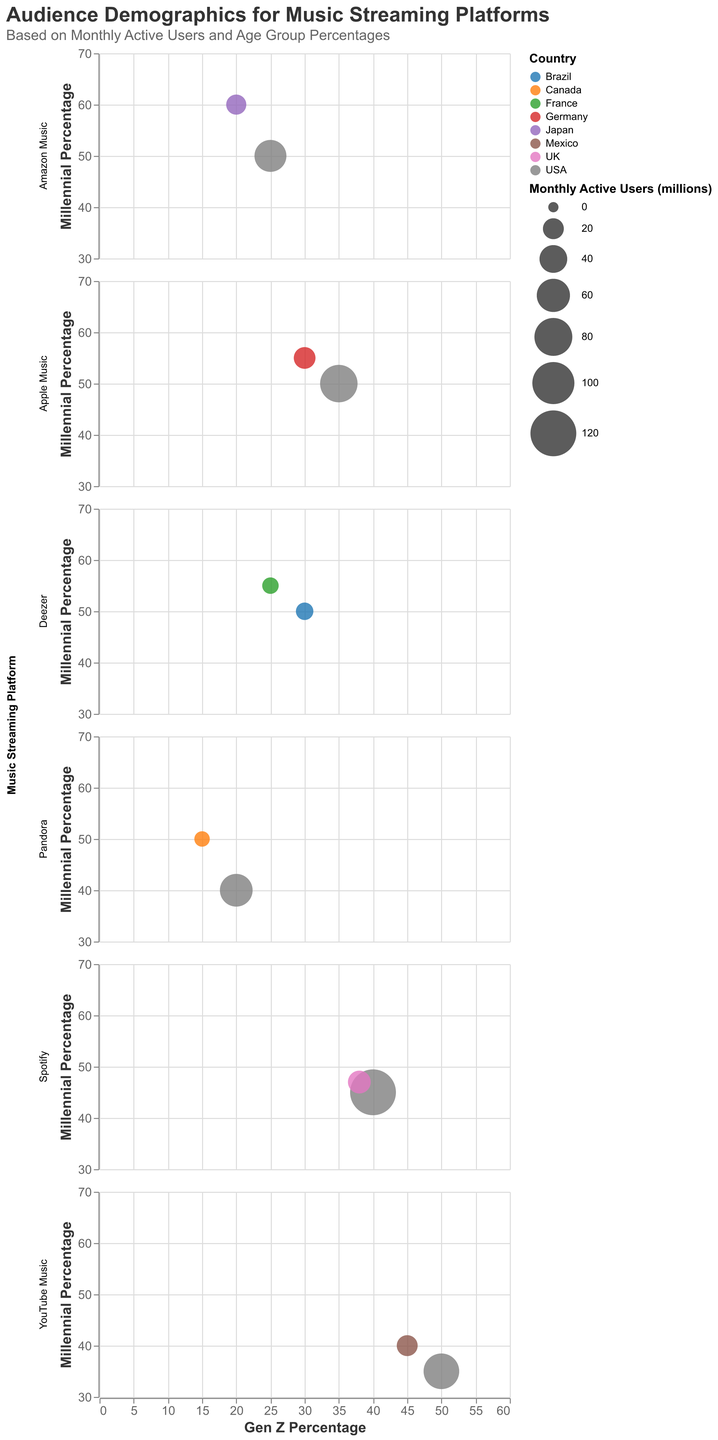What is the platform with the highest percentage of Gen Z users? The subplot with the highest Gen Z percentage can be identified by looking for the circle that is furthest to the right on the x-axis across all subplots.
Answer: YouTube Music (USA) Which demographic has the largest bubble size in the Spotify subplot? By examining the subplot for Spotify, we need to identify the largest bubble which represents the highest monthly active users.
Answer: USA What is the average listening time for Amazon Music in Japan? In the subplot for Amazon Music, locate the circle representing Japan and refer to its tooltip for the average listening time information.
Answer: 11 hours Compare the Gen Z and Millennial percentages for YouTube Music in Mexico. Which is higher? For YouTube Music in Mexico, we compare the position of the corresponding circle on the x and y axes. The circle should be further right for Gen Z if it is higher and further up for Millennials if it is higher.
Answer: Gen Z Which platform in the USA has the smallest percentage of Gen Z users? Focus on the subplots for platforms that include the USA and identify the one with the lowest x-axis value for the USA circle.
Answer: Pandora How do the monthly active users of Apple Music in Germany compare to Deezer in France? Compare the bubble sizes by looking at the subplots for Apple Music (Germany) and Deezer (France) to determine which one is larger.
Answer: Apple Music in Germany has more users What is the sum of the Millennial percentages for Deezer in France and Brazil? Locate the circles for Deezer in France and Brazil and add their y-axis values. France has 55% Millennial percentage and Brazil has 50%.
Answer: 105% Which platform has the highest average listening time and for which demographic? Find the circle in all subplots that is positioned highest on the y-axis, then check its tooltip to confirm the exact average listening time and corresponding demographic.
Answer: YouTube Music (Mexico) What is the Boomer percentage for Pandora in Canada? Locate the Pandora subplot, find the circle for Canada, and refer to its tooltip for the Boomer percentage.
Answer: 35% Which has more monthly active users: Spotify in the UK or Amazon Music in the USA? Compare the size of the bubbles in the Spotify (UK) and Amazon Music (USA) subplots where a larger bubble indicates more users.
Answer: Spotify in the UK 